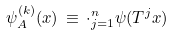<formula> <loc_0><loc_0><loc_500><loc_500>\psi _ { A } ^ { ( k ) } ( x ) \, \equiv \, \cdot _ { j = 1 } ^ { n } \psi ( T ^ { j } x )</formula> 